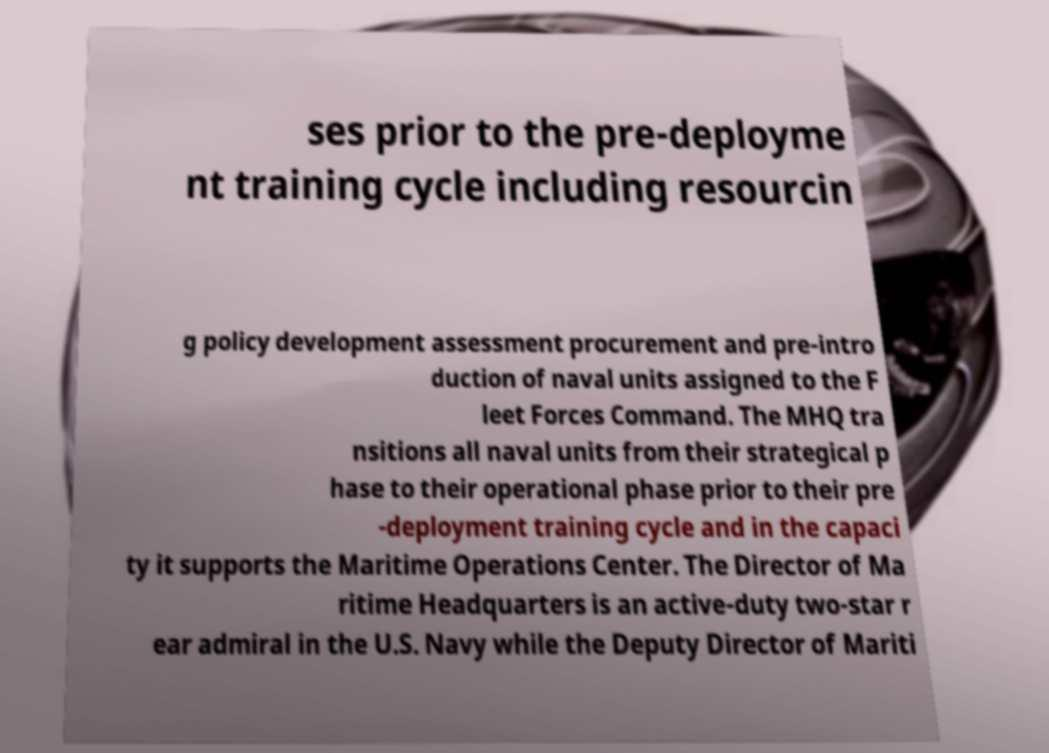Please read and relay the text visible in this image. What does it say? ses prior to the pre-deployme nt training cycle including resourcin g policy development assessment procurement and pre-intro duction of naval units assigned to the F leet Forces Command. The MHQ tra nsitions all naval units from their strategical p hase to their operational phase prior to their pre -deployment training cycle and in the capaci ty it supports the Maritime Operations Center. The Director of Ma ritime Headquarters is an active-duty two-star r ear admiral in the U.S. Navy while the Deputy Director of Mariti 